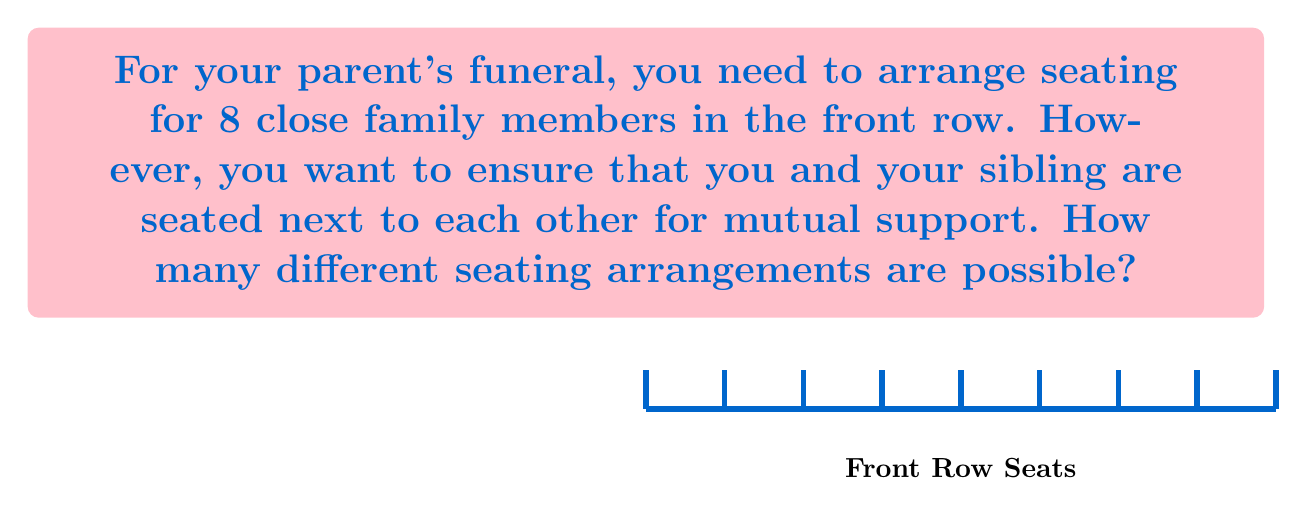What is the answer to this math problem? Let's approach this step-by-step:

1) First, consider you and your sibling as a single unit. This means we effectively have 7 units to arrange (you+sibling, and 6 other family members).

2) The number of ways to arrange 7 distinct units is given by the permutation formula:
   $$P(7,7) = 7! = 7 \times 6 \times 5 \times 4 \times 3 \times 2 \times 1 = 5040$$

3) However, you and your sibling can also switch positions within your unit. This doubles the number of possibilities for each arrangement.

4) Therefore, the total number of possible arrangements is:
   $$5040 \times 2 = 10080$$

This calculation takes into account all possible arrangements of the family members while keeping you and your sibling together, and considers the two ways you and your sibling can be ordered within your pair.
Answer: $10080$ 